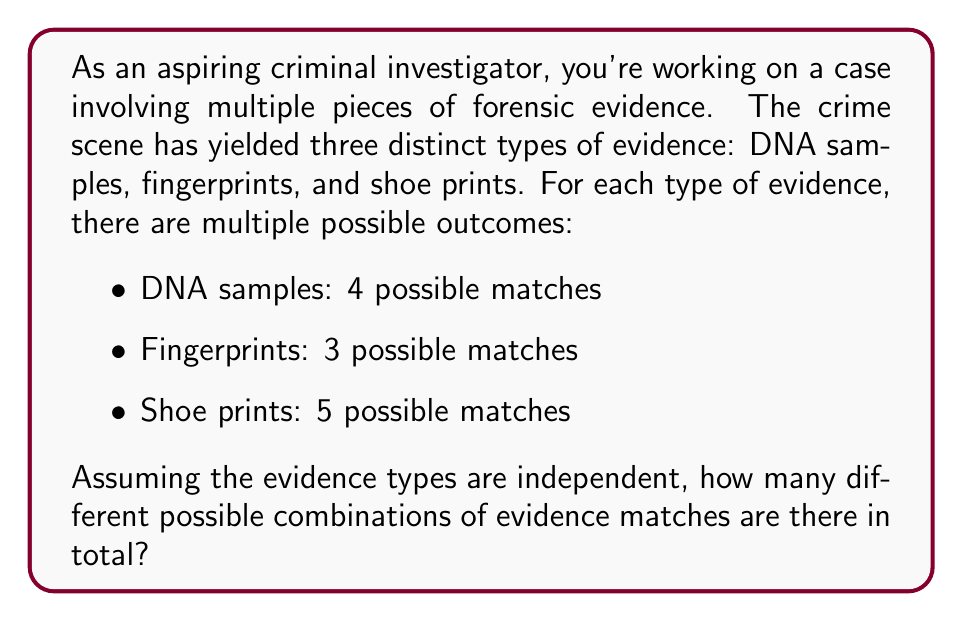Help me with this question. To solve this problem, we need to use the multiplication principle of counting. This principle states that if we have independent events, the total number of possible outcomes is the product of the number of possibilities for each event.

Let's break it down step by step:

1. For DNA samples, there are 4 possible matches.
2. For fingerprints, there are 3 possible matches.
3. For shoe prints, there are 5 possible matches.

Since these evidence types are independent (the outcome of one doesn't affect the others), we multiply these numbers together:

$$ \text{Total combinations} = 4 \times 3 \times 5 $$

This gives us:

$$ \text{Total combinations} = 60 $$

This means that there are 60 different possible combinations of evidence matches that an investigator might encounter when analyzing these three types of forensic evidence.

To visualize this, we can think of it as a tree diagram with 4 branches for DNA, each of those splitting into 3 branches for fingerprints, and each of those further splitting into 5 branches for shoe prints. The total number of end points on this tree would be 60.
Answer: 60 possible combinations 